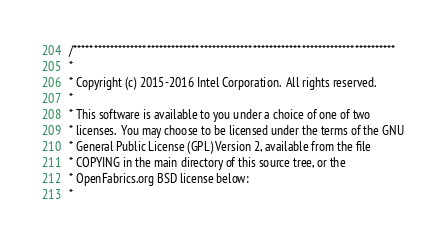<code> <loc_0><loc_0><loc_500><loc_500><_C_>/*******************************************************************************
*
* Copyright (c) 2015-2016 Intel Corporation.  All rights reserved.
*
* This software is available to you under a choice of one of two
* licenses.  You may choose to be licensed under the terms of the GNU
* General Public License (GPL) Version 2, available from the file
* COPYING in the main directory of this source tree, or the
* OpenFabrics.org BSD license below:
*</code> 